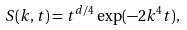<formula> <loc_0><loc_0><loc_500><loc_500>S ( k , t ) = t ^ { d / 4 } \exp ( - 2 k ^ { 4 } t ) ,</formula> 